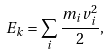<formula> <loc_0><loc_0><loc_500><loc_500>E _ { k } = \sum _ { i } \frac { m _ { i } v _ { i } ^ { 2 } } { 2 } ,</formula> 